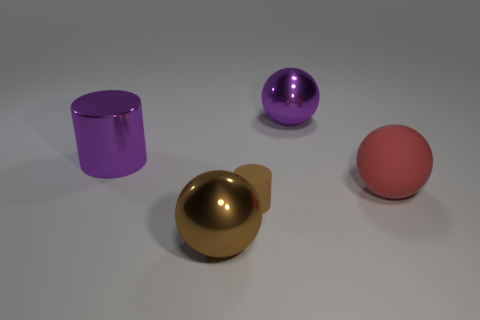Do the tiny matte thing and the big purple thing that is to the left of the small brown object have the same shape?
Provide a succinct answer. Yes. What is the material of the sphere that is right of the large purple object on the right side of the purple shiny thing that is in front of the purple metal sphere?
Offer a terse response. Rubber. Is there a red rubber sphere of the same size as the brown cylinder?
Your response must be concise. No. What is the size of the other object that is the same material as the red thing?
Keep it short and to the point. Small. What shape is the tiny brown matte thing?
Your answer should be very brief. Cylinder. Is the large purple ball made of the same material as the big ball that is left of the brown matte thing?
Provide a short and direct response. Yes. What number of objects are brown matte cylinders or large red metal objects?
Your answer should be very brief. 1. Are there any tiny balls?
Provide a succinct answer. No. The big shiny thing that is in front of the big metallic object on the left side of the big brown sphere is what shape?
Ensure brevity in your answer.  Sphere. What number of objects are balls behind the large red thing or purple metal objects that are to the right of the small brown thing?
Your answer should be compact. 1. 